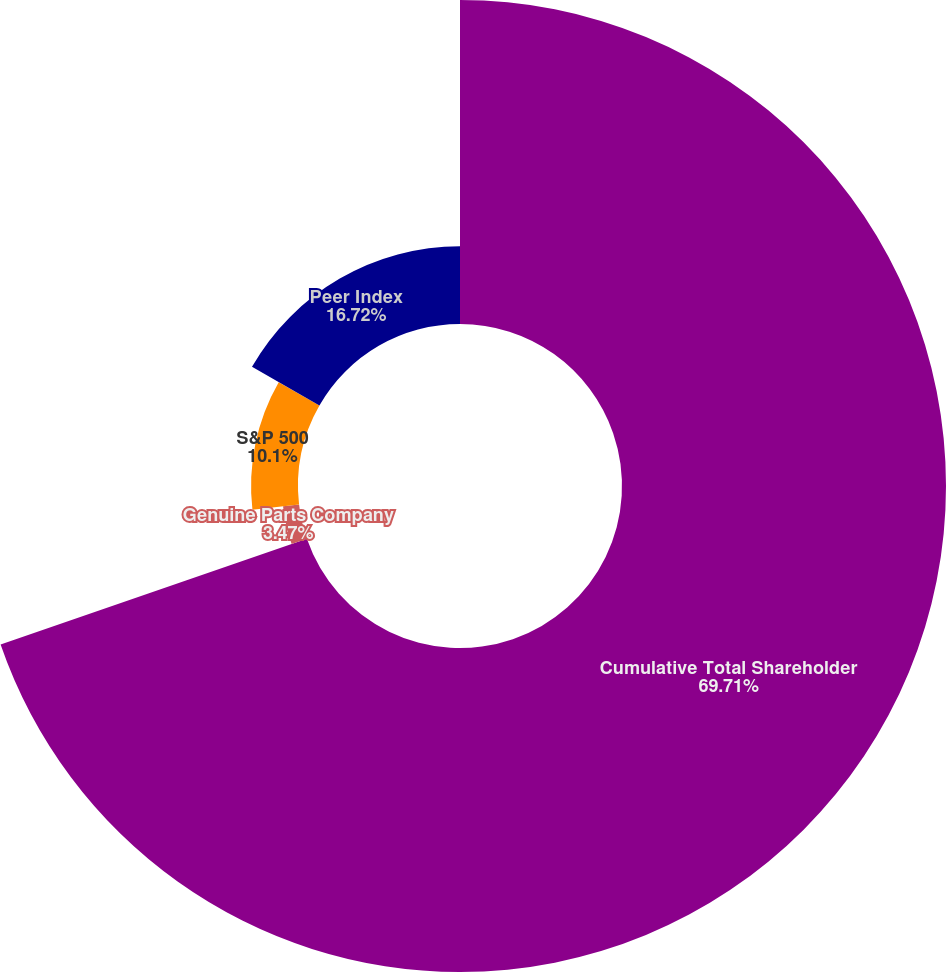Convert chart. <chart><loc_0><loc_0><loc_500><loc_500><pie_chart><fcel>Cumulative Total Shareholder<fcel>Genuine Parts Company<fcel>S&P 500<fcel>Peer Index<nl><fcel>69.71%<fcel>3.47%<fcel>10.1%<fcel>16.72%<nl></chart> 